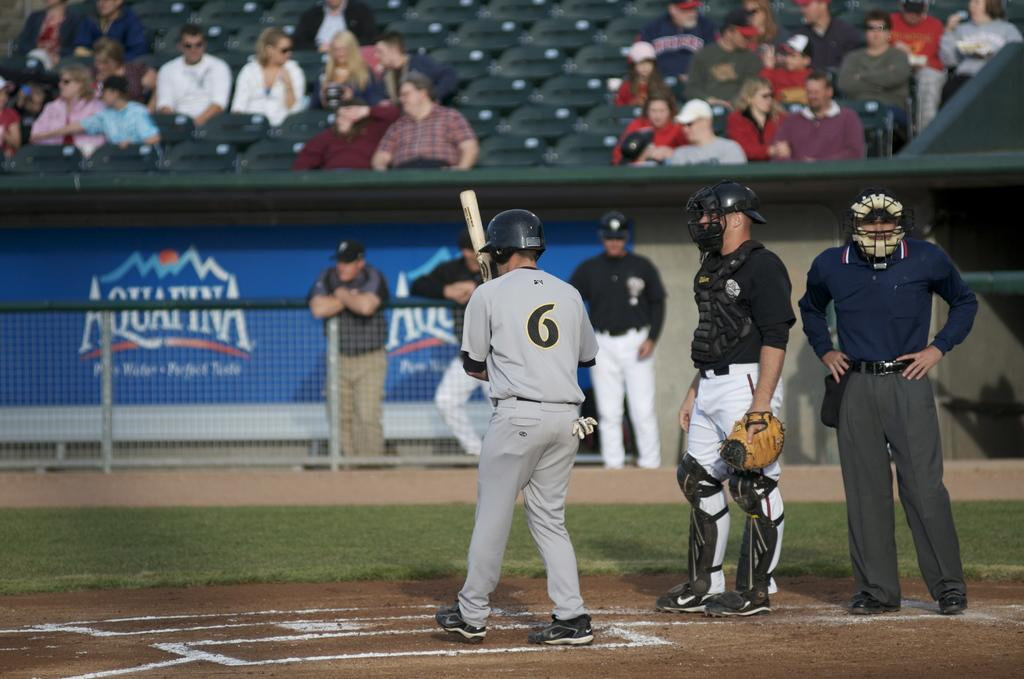<image>
Relay a brief, clear account of the picture shown. aquafina is a sponsor of the ball field that the people are playing on 